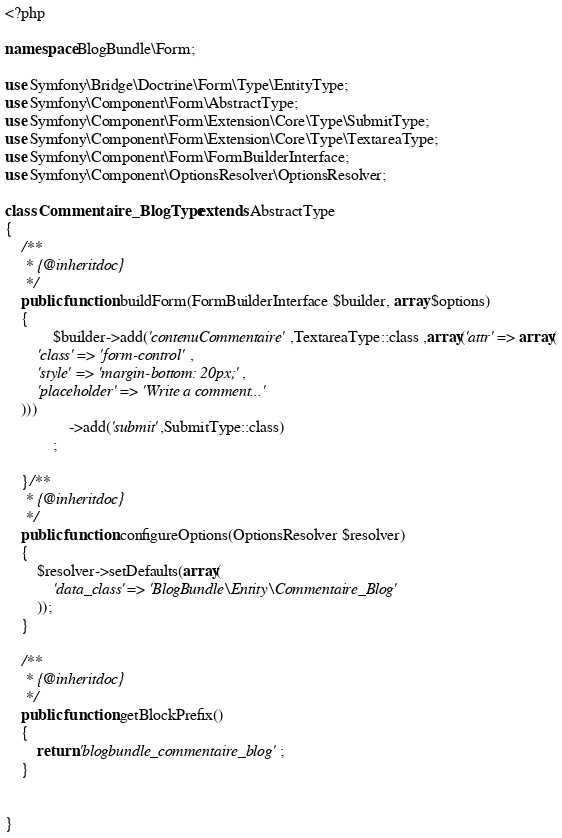Convert code to text. <code><loc_0><loc_0><loc_500><loc_500><_PHP_><?php

namespace BlogBundle\Form;

use Symfony\Bridge\Doctrine\Form\Type\EntityType;
use Symfony\Component\Form\AbstractType;
use Symfony\Component\Form\Extension\Core\Type\SubmitType;
use Symfony\Component\Form\Extension\Core\Type\TextareaType;
use Symfony\Component\Form\FormBuilderInterface;
use Symfony\Component\OptionsResolver\OptionsResolver;

class Commentaire_BlogType extends AbstractType
{
    /**
     * {@inheritdoc}
     */
    public function buildForm(FormBuilderInterface $builder, array $options)
    {
            $builder->add('contenuCommentaire',TextareaType::class ,array('attr' => array(
        'class' => 'form-control' ,
        'style' => 'margin-bottom: 20px;',
        'placeholder' => 'Write a comment...'
    )))
                ->add('submit',SubmitType::class)
            ;

    }/**
     * {@inheritdoc}
     */
    public function configureOptions(OptionsResolver $resolver)
    {
        $resolver->setDefaults(array(
            'data_class' => 'BlogBundle\Entity\Commentaire_Blog'
        ));
    }

    /**
     * {@inheritdoc}
     */
    public function getBlockPrefix()
    {
        return 'blogbundle_commentaire_blog';
    }


}
</code> 